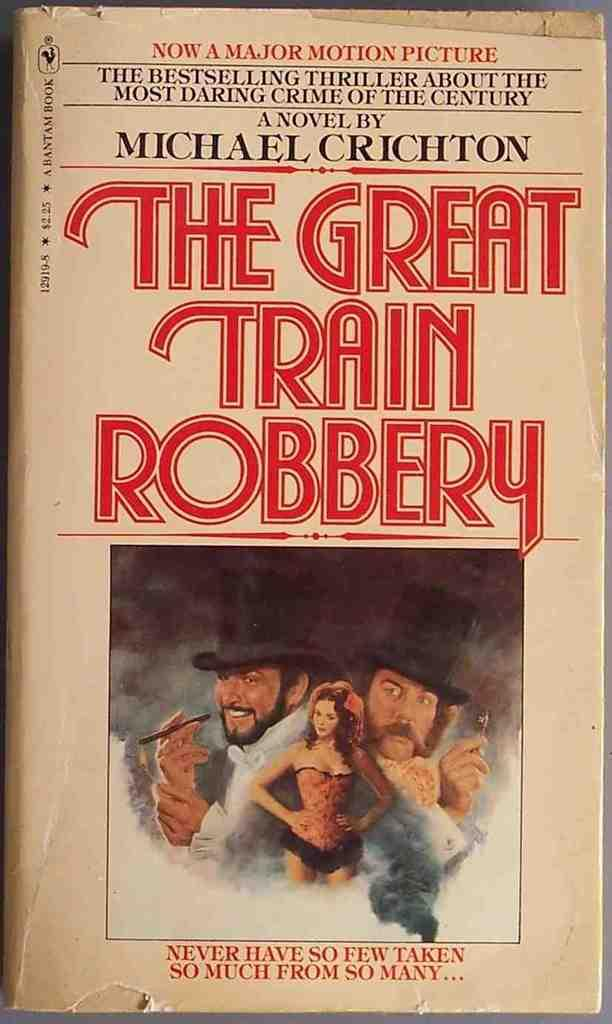What object can be seen in the image? There is a book in the image. Can you describe the book in the image? The book appears to be a hardcover book with a visible spine. What might someone be doing with the book in the image? Someone might be reading or holding the book in the image. How many cows are visible in the image? There are no cows visible in the image; it features a book. 